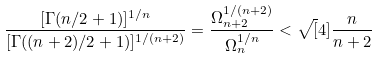Convert formula to latex. <formula><loc_0><loc_0><loc_500><loc_500>\frac { [ \Gamma ( n / 2 + 1 ) ] ^ { 1 / n } } { [ \Gamma ( ( n + 2 ) / 2 + 1 ) ] ^ { 1 / ( n + 2 ) } } = \frac { \Omega _ { n + 2 } ^ { 1 / ( n + 2 ) } } { \Omega _ { n } ^ { 1 / n } } < \sqrt { [ } 4 ] { \frac { n } { n + 2 } } \,</formula> 